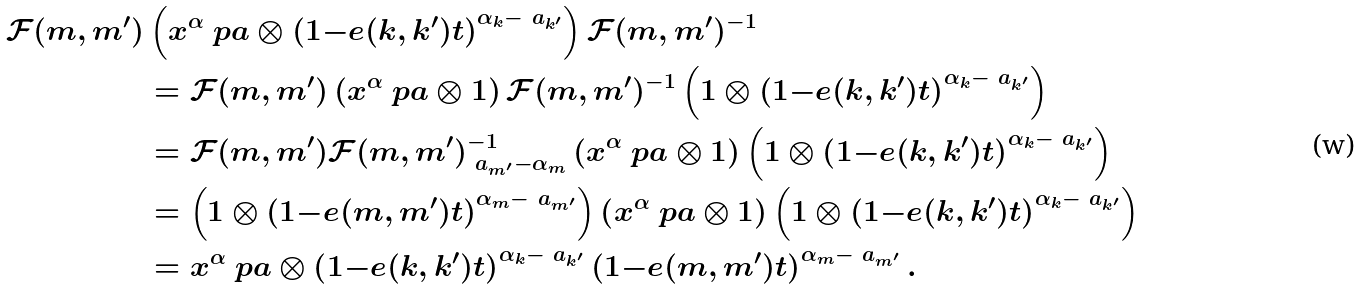Convert formula to latex. <formula><loc_0><loc_0><loc_500><loc_500>\mathcal { F } ( m , m ^ { \prime } ) & \left ( x ^ { \alpha } \ p a \otimes \left ( 1 { - } e ( k , k ^ { \prime } ) t \right ) ^ { \alpha _ { k } { - } \ a _ { k ^ { \prime } } } \right ) \mathcal { F } ( m , m ^ { \prime } ) ^ { - 1 } \\ & = \mathcal { F } ( m , m ^ { \prime } ) \left ( x ^ { \alpha } \ p a \otimes 1 \right ) \mathcal { F } ( m , m ^ { \prime } ) ^ { - 1 } \left ( 1 \otimes \left ( 1 { - } e ( k , k ^ { \prime } ) t \right ) ^ { \alpha _ { k } { - } \ a _ { k ^ { \prime } } } \right ) \\ & = \mathcal { F } ( m , m ^ { \prime } ) \mathcal { F } ( m , m ^ { \prime } ) ^ { - 1 } _ { \ a _ { m ^ { \prime } } { - } \alpha _ { m } } \left ( x ^ { \alpha } \ p a \otimes 1 \right ) \left ( 1 \otimes \left ( 1 { - } e ( k , k ^ { \prime } ) t \right ) ^ { \alpha _ { k } { - } \ a _ { k ^ { \prime } } } \right ) \\ & = \left ( 1 \otimes \left ( 1 { - } e ( m , m ^ { \prime } ) t \right ) ^ { \alpha _ { m } { - } \ a _ { m ^ { \prime } } } \right ) \left ( x ^ { \alpha } \ p a \otimes 1 \right ) \left ( 1 \otimes \left ( 1 { - } e ( k , k ^ { \prime } ) t \right ) ^ { \alpha _ { k } { - } \ a _ { k ^ { \prime } } } \right ) \\ & = x ^ { \alpha } \ p a \otimes \left ( 1 { - } e ( k , k ^ { \prime } ) t \right ) ^ { \alpha _ { k } { - } \ a _ { k ^ { \prime } } } \left ( 1 { - } e ( m , m ^ { \prime } ) t \right ) ^ { \alpha _ { m } { - } \ a _ { m ^ { \prime } } } .</formula> 